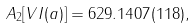Convert formula to latex. <formula><loc_0><loc_0><loc_500><loc_500>A _ { 2 } [ V I ( a ) ] = 6 2 9 . 1 4 0 7 ( 1 1 8 ) ,</formula> 